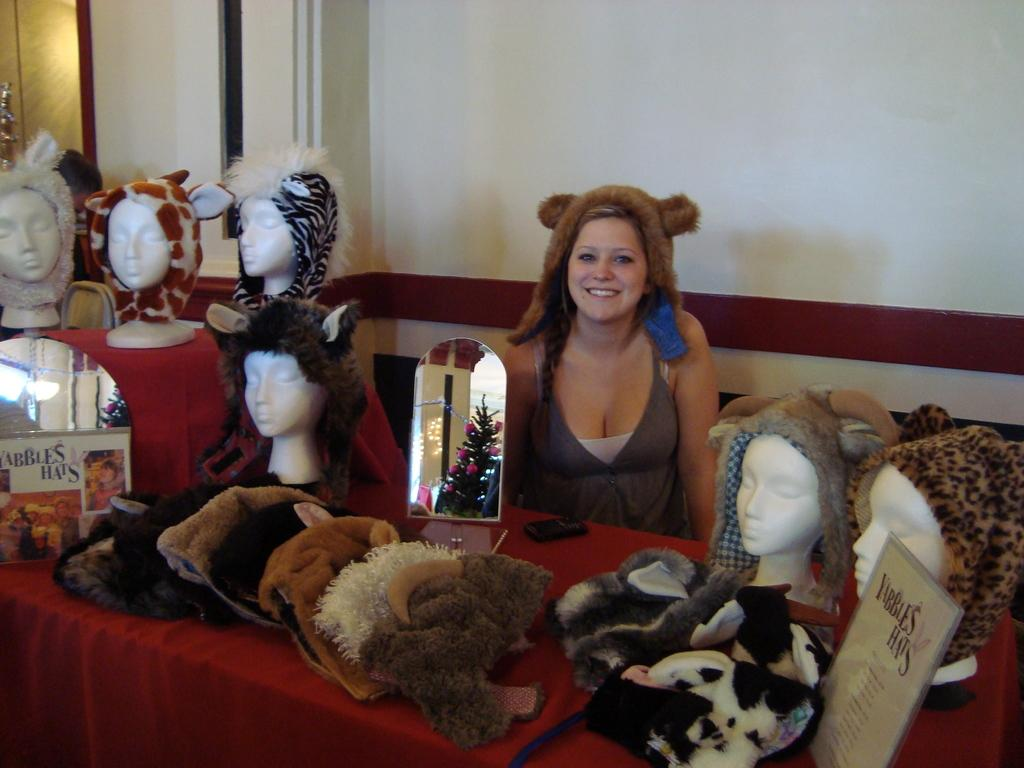Who is present in the image? There is a woman in the image. What is the woman's expression? The woman is smiling. What type of items can be seen in the image? Clothes, a mobile, name boards, a mirror, and mannequin heads are visible in the image. What is the background of the image? There is a wall in the background of the image. What type of beast can be seen interacting with the woman in the image? There is no beast present in the image; it only features a woman, clothes, a mobile, name boards, a mirror, and mannequin heads. What type of coach is visible in the image? There is no coach present in the image. 